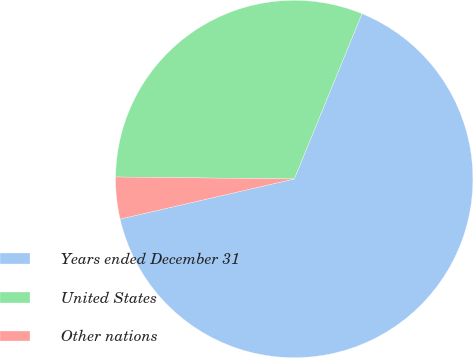Convert chart to OTSL. <chart><loc_0><loc_0><loc_500><loc_500><pie_chart><fcel>Years ended December 31<fcel>United States<fcel>Other nations<nl><fcel>65.21%<fcel>31.01%<fcel>3.78%<nl></chart> 